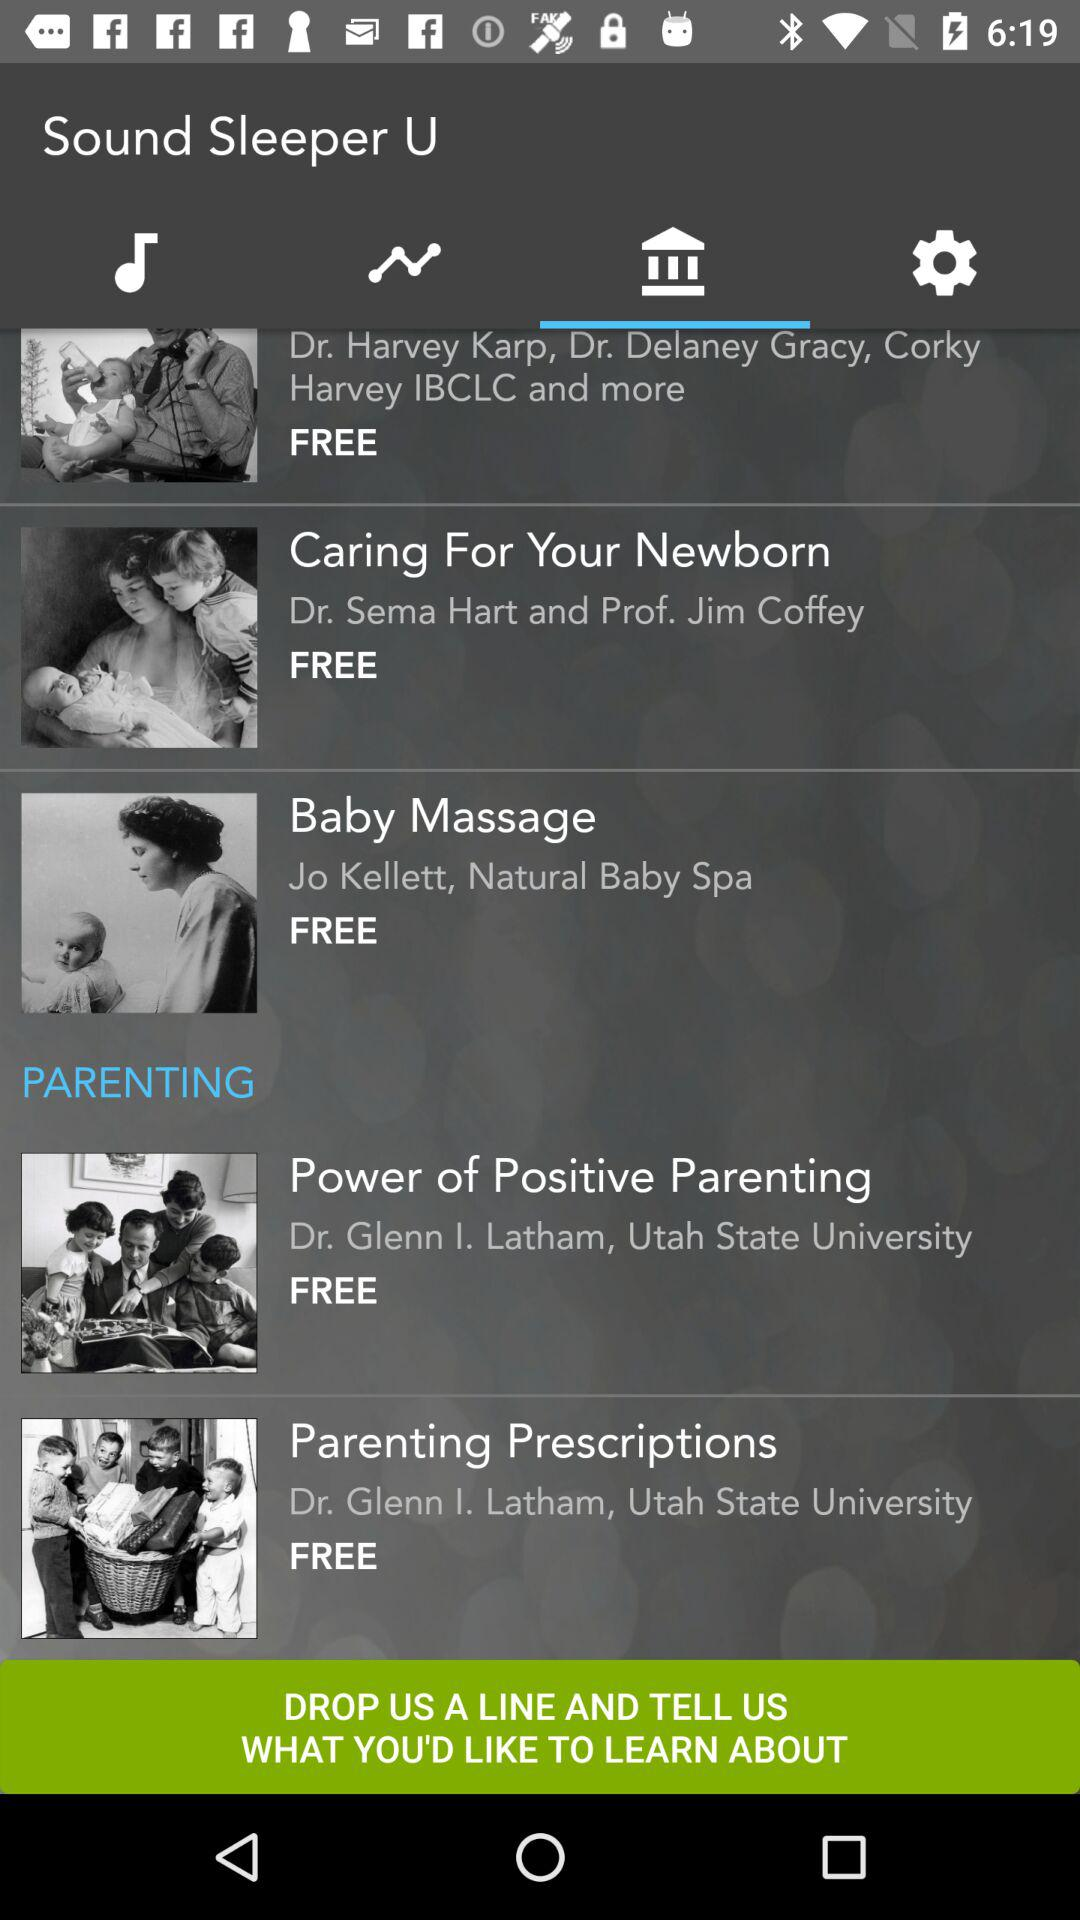What is the cost of the "Baby Massage"? The "Baby Massage" is free of cost. 